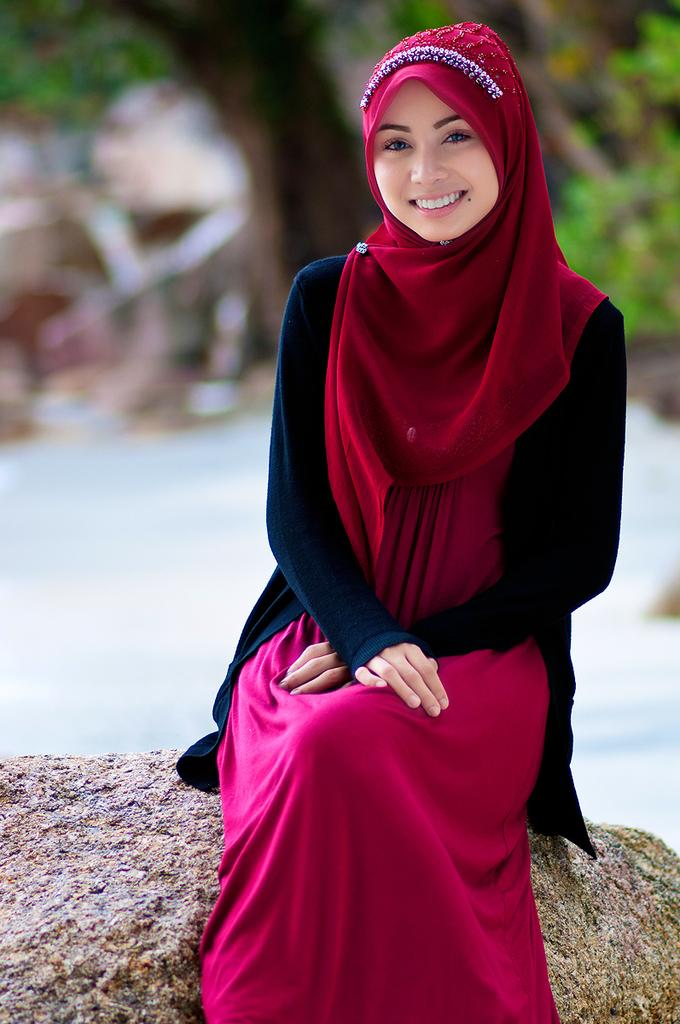Who is the main subject in the foreground of the image? There is a woman in the foreground of the image. What is the woman doing in the image? The woman is sitting. What is the woman's facial expression in the image? The woman is smiling. What can be seen in the background of the image? There are trees and houses in the background of the image. What type of muscle is the woman exercising in the image? There is no indication in the image that the woman is exercising or focusing on a specific muscle. 